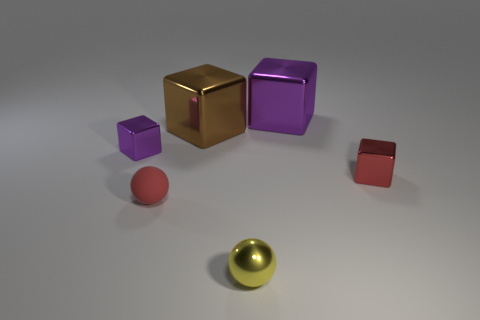Are there any other things that have the same material as the tiny red ball?
Keep it short and to the point. No. How many small cubes are behind the purple metallic thing behind the tiny metal cube left of the small red ball?
Make the answer very short. 0. There is a brown thing that is the same shape as the red metal object; what is it made of?
Provide a short and direct response. Metal. What color is the thing to the left of the small red ball?
Ensure brevity in your answer.  Purple. Are the tiny red cube and the tiny yellow object that is in front of the brown block made of the same material?
Offer a very short reply. Yes. What is the red ball made of?
Your answer should be compact. Rubber. There is a small yellow object that is made of the same material as the brown thing; what is its shape?
Your answer should be compact. Sphere. How many other things are the same shape as the small purple metallic thing?
Provide a short and direct response. 3. How many small shiny blocks are on the left side of the red metallic cube?
Your response must be concise. 1. There is a purple shiny block on the right side of the tiny purple metallic block; is it the same size as the metallic block on the left side of the red rubber thing?
Your answer should be compact. No. 